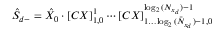<formula> <loc_0><loc_0><loc_500><loc_500>\hat { S } _ { d - } = \hat { X } _ { 0 } \cdot { [ C X ] } _ { 1 , 0 } ^ { 1 } \cdots { [ C X ] } _ { 1 \dots \bar { \log _ { 2 } { ( N _ { x _ { d } } ) } - 1 } , 0 } ^ { \log _ { 2 } { ( N _ { x _ { d } } ) } - 1 }</formula> 